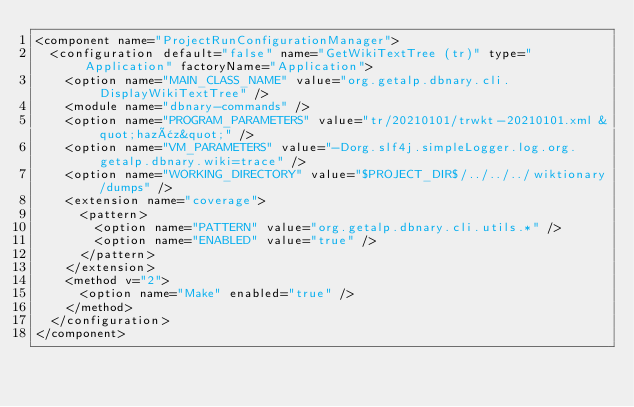Convert code to text. <code><loc_0><loc_0><loc_500><loc_500><_XML_><component name="ProjectRunConfigurationManager">
  <configuration default="false" name="GetWikiTextTree (tr)" type="Application" factoryName="Application">
    <option name="MAIN_CLASS_NAME" value="org.getalp.dbnary.cli.DisplayWikiTextTree" />
    <module name="dbnary-commands" />
    <option name="PROGRAM_PARAMETERS" value="tr/20210101/trwkt-20210101.xml &quot;hazâz&quot;" />
    <option name="VM_PARAMETERS" value="-Dorg.slf4j.simpleLogger.log.org.getalp.dbnary.wiki=trace" />
    <option name="WORKING_DIRECTORY" value="$PROJECT_DIR$/../../../wiktionary/dumps" />
    <extension name="coverage">
      <pattern>
        <option name="PATTERN" value="org.getalp.dbnary.cli.utils.*" />
        <option name="ENABLED" value="true" />
      </pattern>
    </extension>
    <method v="2">
      <option name="Make" enabled="true" />
    </method>
  </configuration>
</component></code> 